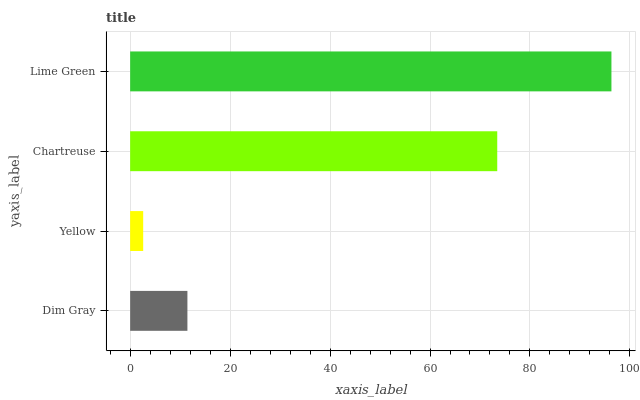Is Yellow the minimum?
Answer yes or no. Yes. Is Lime Green the maximum?
Answer yes or no. Yes. Is Chartreuse the minimum?
Answer yes or no. No. Is Chartreuse the maximum?
Answer yes or no. No. Is Chartreuse greater than Yellow?
Answer yes or no. Yes. Is Yellow less than Chartreuse?
Answer yes or no. Yes. Is Yellow greater than Chartreuse?
Answer yes or no. No. Is Chartreuse less than Yellow?
Answer yes or no. No. Is Chartreuse the high median?
Answer yes or no. Yes. Is Dim Gray the low median?
Answer yes or no. Yes. Is Yellow the high median?
Answer yes or no. No. Is Chartreuse the low median?
Answer yes or no. No. 